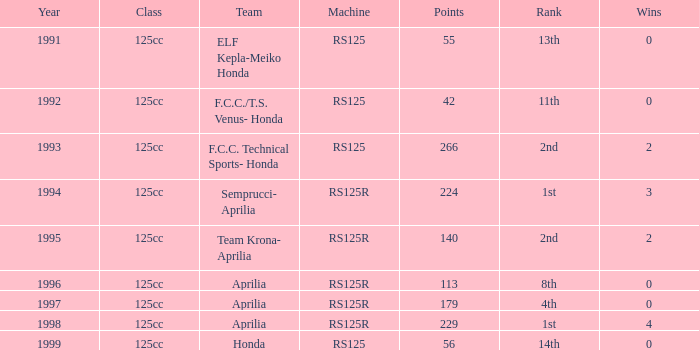In which group was there a machine of rs125r, points above 113, and a standing of 4th place? 125cc. 